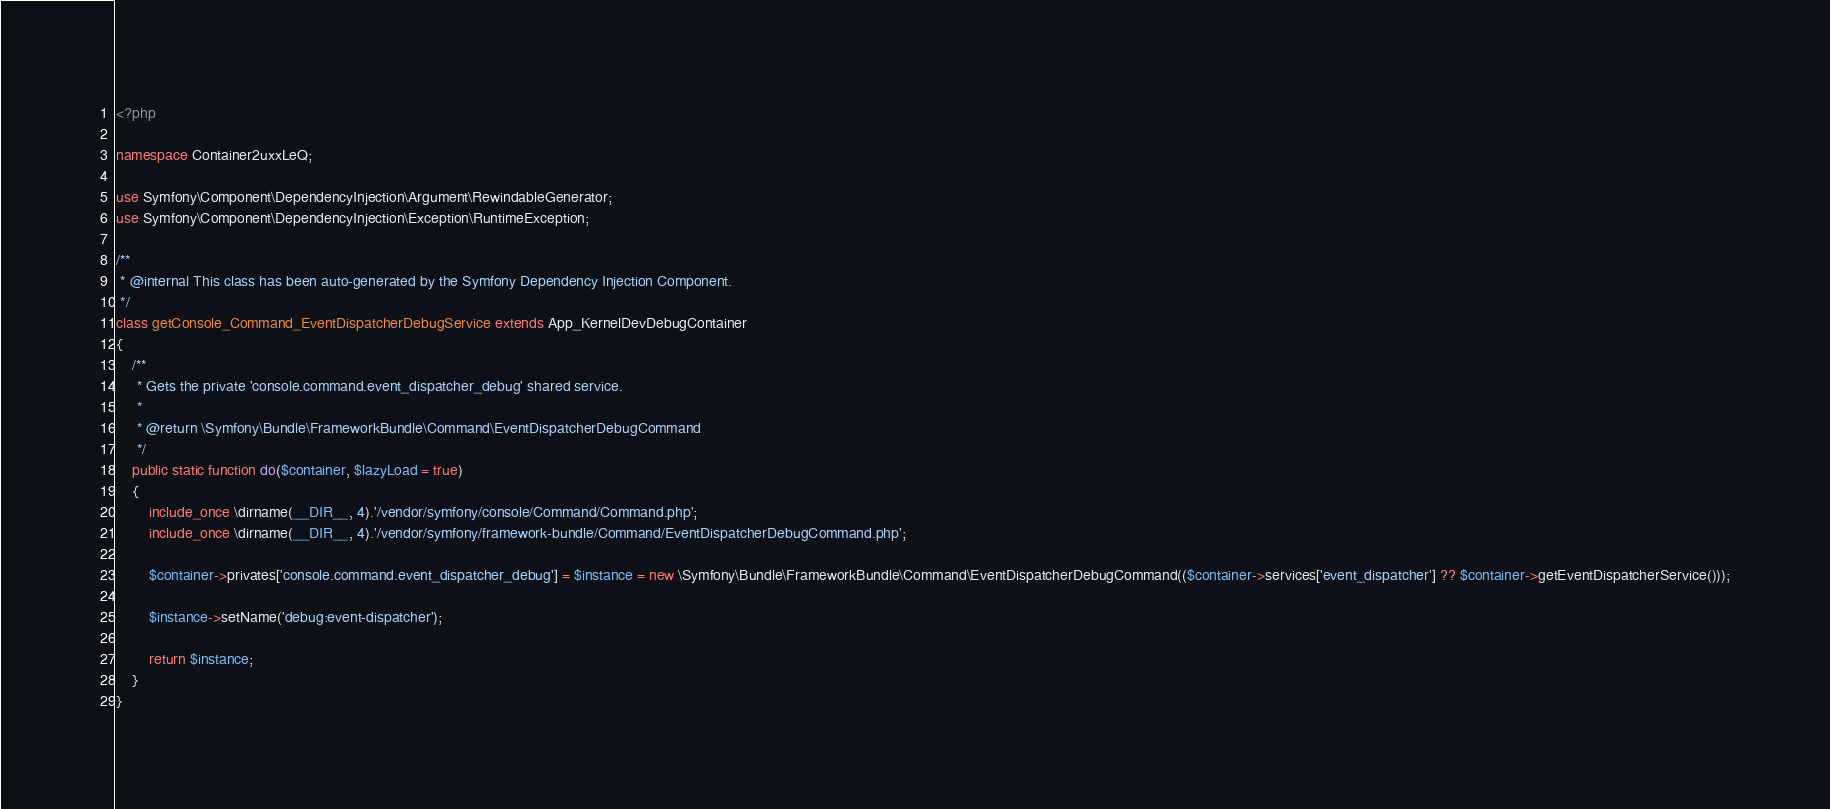<code> <loc_0><loc_0><loc_500><loc_500><_PHP_><?php

namespace Container2uxxLeQ;

use Symfony\Component\DependencyInjection\Argument\RewindableGenerator;
use Symfony\Component\DependencyInjection\Exception\RuntimeException;

/**
 * @internal This class has been auto-generated by the Symfony Dependency Injection Component.
 */
class getConsole_Command_EventDispatcherDebugService extends App_KernelDevDebugContainer
{
    /**
     * Gets the private 'console.command.event_dispatcher_debug' shared service.
     *
     * @return \Symfony\Bundle\FrameworkBundle\Command\EventDispatcherDebugCommand
     */
    public static function do($container, $lazyLoad = true)
    {
        include_once \dirname(__DIR__, 4).'/vendor/symfony/console/Command/Command.php';
        include_once \dirname(__DIR__, 4).'/vendor/symfony/framework-bundle/Command/EventDispatcherDebugCommand.php';

        $container->privates['console.command.event_dispatcher_debug'] = $instance = new \Symfony\Bundle\FrameworkBundle\Command\EventDispatcherDebugCommand(($container->services['event_dispatcher'] ?? $container->getEventDispatcherService()));

        $instance->setName('debug:event-dispatcher');

        return $instance;
    }
}
</code> 